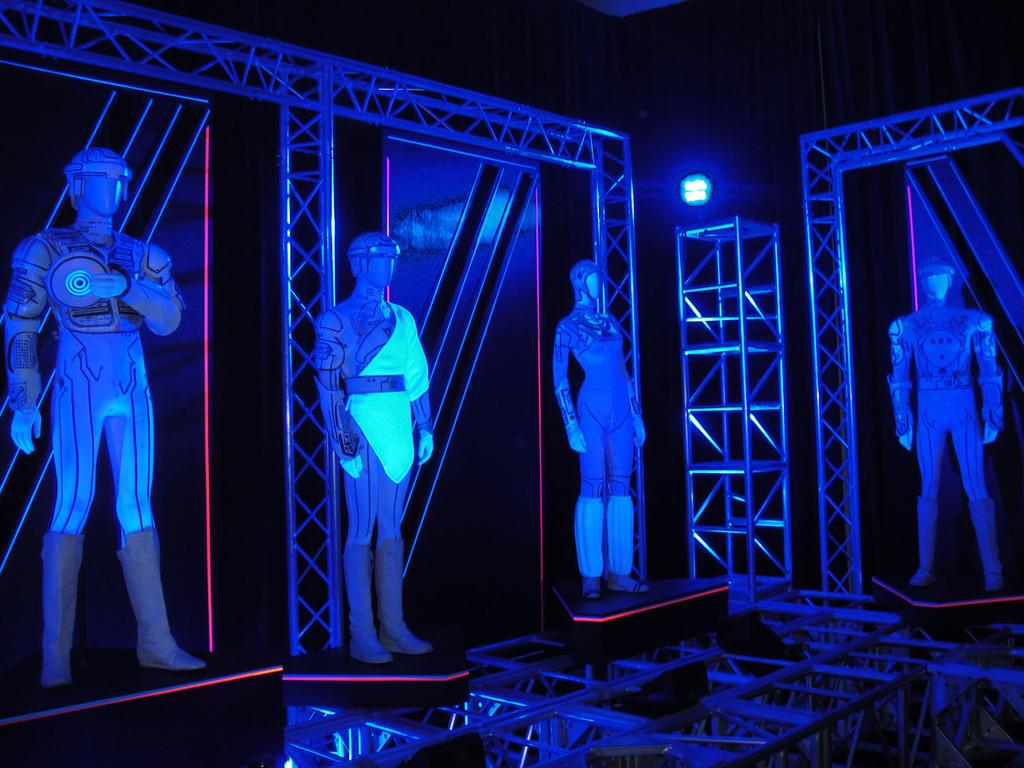What is the main subject of the image? There are depictions of a person in the center of the image. What other objects can be seen in the image? There are rods in the image. What can be seen in the background of the image? There is a light in the background of the image. What rule is being enforced by the person in the image? There is no indication of a rule being enforced in the image; it only shows a person and some rods. How many houses are visible in the image? There are no houses visible in the image. 